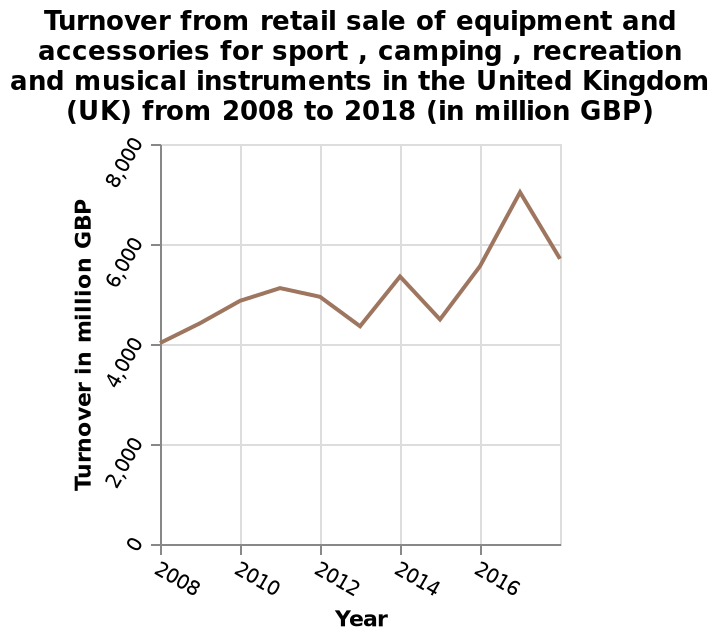<image>
What is the unit of measurement for the values plotted on the y-axis? The unit of measurement for the values plotted on the y-axis is million GBP. What was the sales growth from 2008 to 2018? Sales grew from 4000 million GBP in 2008 to around 5800 million GBP in 2018. 